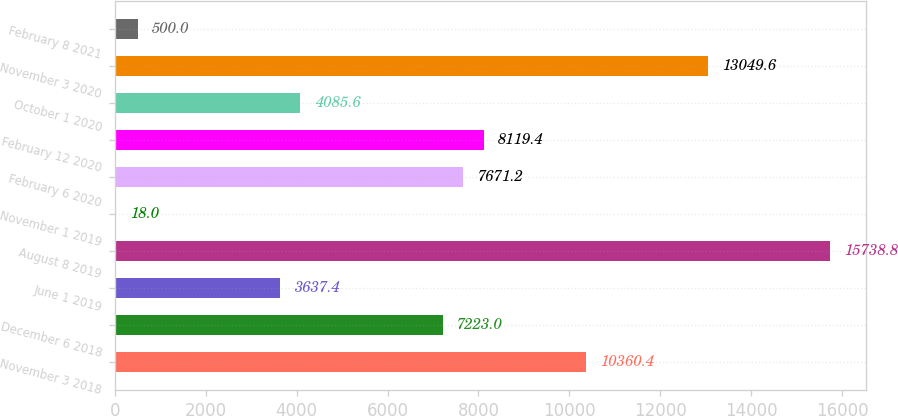Convert chart. <chart><loc_0><loc_0><loc_500><loc_500><bar_chart><fcel>November 3 2018<fcel>December 6 2018<fcel>June 1 2019<fcel>August 8 2019<fcel>November 1 2019<fcel>February 6 2020<fcel>February 12 2020<fcel>October 1 2020<fcel>November 3 2020<fcel>February 8 2021<nl><fcel>10360.4<fcel>7223<fcel>3637.4<fcel>15738.8<fcel>18<fcel>7671.2<fcel>8119.4<fcel>4085.6<fcel>13049.6<fcel>500<nl></chart> 